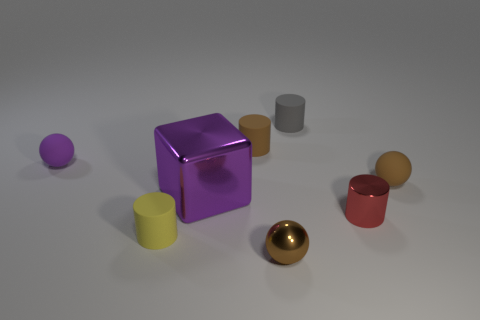Subtract 1 cylinders. How many cylinders are left? 3 Add 1 big red matte things. How many objects exist? 9 Subtract all green cylinders. Subtract all red blocks. How many cylinders are left? 4 Subtract all blocks. How many objects are left? 7 Add 8 large cubes. How many large cubes exist? 9 Subtract 0 blue cylinders. How many objects are left? 8 Subtract all tiny red metallic cylinders. Subtract all tiny rubber cylinders. How many objects are left? 4 Add 6 yellow rubber objects. How many yellow rubber objects are left? 7 